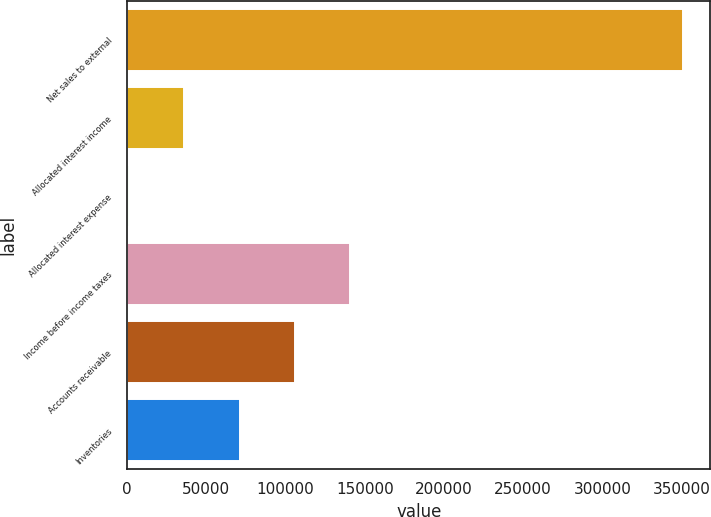Convert chart to OTSL. <chart><loc_0><loc_0><loc_500><loc_500><bar_chart><fcel>Net sales to external<fcel>Allocated interest income<fcel>Allocated interest expense<fcel>Income before income taxes<fcel>Accounts receivable<fcel>Inventories<nl><fcel>350674<fcel>35969.2<fcel>1002<fcel>140871<fcel>105904<fcel>70936.4<nl></chart> 